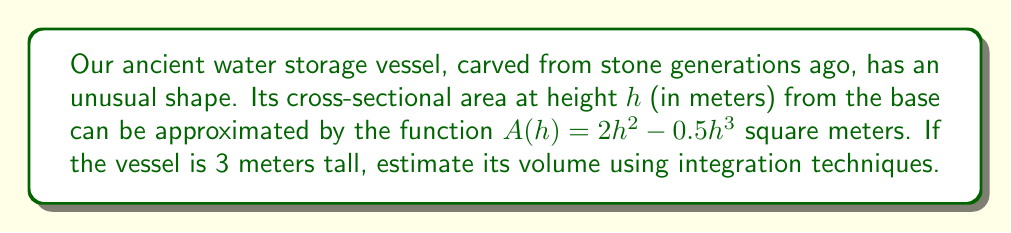Can you answer this question? To find the volume of this irregularly shaped vessel, we need to integrate the cross-sectional area function over the height of the vessel. Here's how we proceed:

1) The volume of a solid with a known cross-sectional area function $A(h)$ from height $a$ to $b$ is given by:

   $$V = \int_a^b A(h) \, dh$$

2) In this case, $a = 0$ (base of the vessel), $b = 3$ (height of the vessel), and $A(h) = 2h^2 - 0.5h^3$. So our integral becomes:

   $$V = \int_0^3 (2h^2 - 0.5h^3) \, dh$$

3) Let's integrate this function:
   
   $$V = \left[ \frac{2h^3}{3} - \frac{0.5h^4}{4} \right]_0^3$$

4) Now we evaluate the integral at the limits:

   $$V = \left( \frac{2(3^3)}{3} - \frac{0.5(3^4)}{4} \right) - \left( \frac{2(0^3)}{3} - \frac{0.5(0^4)}{4} \right)$$

5) Simplify:
   
   $$V = \left( 18 - \frac{40.5}{4} \right) - 0 = 18 - 10.125 = 7.875$$

Therefore, the volume of the ancient water storage vessel is approximately 7.875 cubic meters.
Answer: $7.875 \text{ m}^3$ 